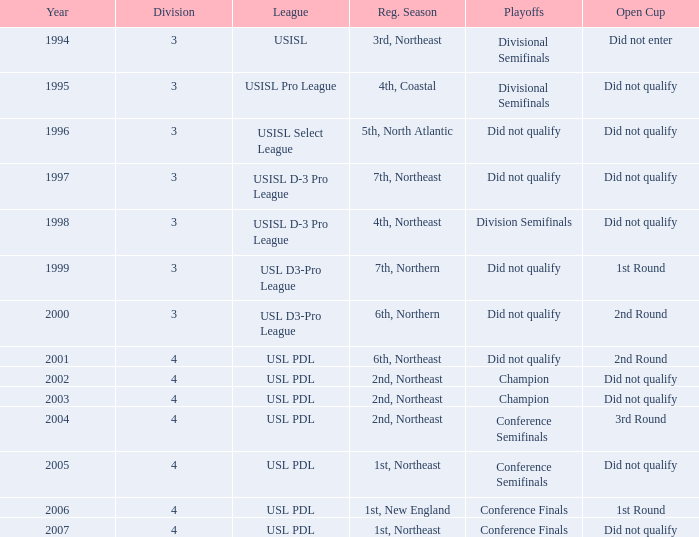How many years in total does the usl pro league encompass? 1.0. 